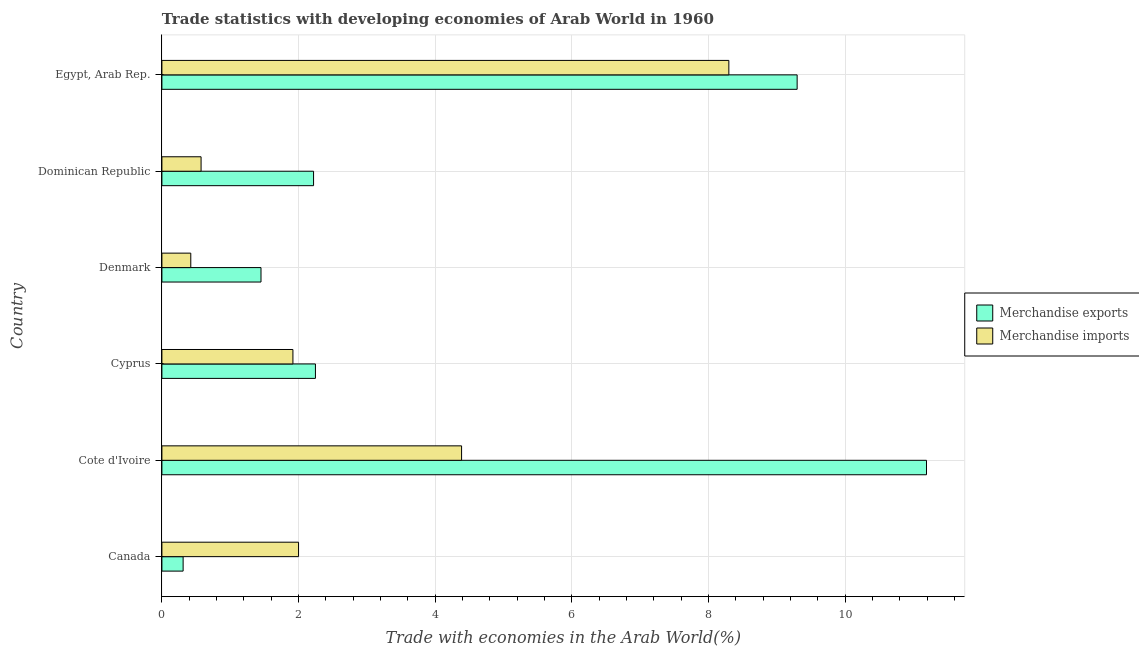How many different coloured bars are there?
Your response must be concise. 2. Are the number of bars per tick equal to the number of legend labels?
Keep it short and to the point. Yes. Are the number of bars on each tick of the Y-axis equal?
Offer a terse response. Yes. How many bars are there on the 6th tick from the bottom?
Your response must be concise. 2. What is the label of the 2nd group of bars from the top?
Offer a very short reply. Dominican Republic. What is the merchandise imports in Egypt, Arab Rep.?
Your response must be concise. 8.3. Across all countries, what is the maximum merchandise exports?
Ensure brevity in your answer.  11.19. Across all countries, what is the minimum merchandise imports?
Ensure brevity in your answer.  0.42. In which country was the merchandise exports maximum?
Give a very brief answer. Cote d'Ivoire. What is the total merchandise imports in the graph?
Your answer should be very brief. 17.6. What is the difference between the merchandise imports in Cote d'Ivoire and that in Dominican Republic?
Your answer should be very brief. 3.81. What is the difference between the merchandise exports in Cote d'Ivoire and the merchandise imports in Egypt, Arab Rep.?
Give a very brief answer. 2.89. What is the average merchandise imports per country?
Make the answer very short. 2.93. What is the difference between the merchandise imports and merchandise exports in Cyprus?
Give a very brief answer. -0.33. In how many countries, is the merchandise exports greater than 4.8 %?
Your answer should be compact. 2. What is the ratio of the merchandise imports in Cote d'Ivoire to that in Cyprus?
Your response must be concise. 2.29. Is the merchandise imports in Cyprus less than that in Egypt, Arab Rep.?
Ensure brevity in your answer.  Yes. Is the difference between the merchandise exports in Canada and Dominican Republic greater than the difference between the merchandise imports in Canada and Dominican Republic?
Provide a short and direct response. No. What is the difference between the highest and the second highest merchandise exports?
Your answer should be very brief. 1.89. What is the difference between the highest and the lowest merchandise exports?
Give a very brief answer. 10.88. Is the sum of the merchandise exports in Cyprus and Dominican Republic greater than the maximum merchandise imports across all countries?
Your response must be concise. No. How many countries are there in the graph?
Provide a short and direct response. 6. Are the values on the major ticks of X-axis written in scientific E-notation?
Ensure brevity in your answer.  No. Does the graph contain any zero values?
Your answer should be very brief. No. What is the title of the graph?
Your answer should be very brief. Trade statistics with developing economies of Arab World in 1960. Does "All education staff compensation" appear as one of the legend labels in the graph?
Your answer should be compact. No. What is the label or title of the X-axis?
Your response must be concise. Trade with economies in the Arab World(%). What is the Trade with economies in the Arab World(%) of Merchandise exports in Canada?
Provide a short and direct response. 0.31. What is the Trade with economies in the Arab World(%) in Merchandise exports in Cote d'Ivoire?
Your answer should be very brief. 11.19. What is the Trade with economies in the Arab World(%) in Merchandise imports in Cote d'Ivoire?
Your answer should be very brief. 4.39. What is the Trade with economies in the Arab World(%) in Merchandise exports in Cyprus?
Keep it short and to the point. 2.25. What is the Trade with economies in the Arab World(%) in Merchandise imports in Cyprus?
Your response must be concise. 1.92. What is the Trade with economies in the Arab World(%) of Merchandise exports in Denmark?
Make the answer very short. 1.45. What is the Trade with economies in the Arab World(%) in Merchandise imports in Denmark?
Offer a terse response. 0.42. What is the Trade with economies in the Arab World(%) in Merchandise exports in Dominican Republic?
Your answer should be compact. 2.22. What is the Trade with economies in the Arab World(%) in Merchandise imports in Dominican Republic?
Offer a very short reply. 0.57. What is the Trade with economies in the Arab World(%) in Merchandise exports in Egypt, Arab Rep.?
Ensure brevity in your answer.  9.3. What is the Trade with economies in the Arab World(%) of Merchandise imports in Egypt, Arab Rep.?
Offer a very short reply. 8.3. Across all countries, what is the maximum Trade with economies in the Arab World(%) of Merchandise exports?
Ensure brevity in your answer.  11.19. Across all countries, what is the maximum Trade with economies in the Arab World(%) of Merchandise imports?
Offer a very short reply. 8.3. Across all countries, what is the minimum Trade with economies in the Arab World(%) of Merchandise exports?
Offer a terse response. 0.31. Across all countries, what is the minimum Trade with economies in the Arab World(%) in Merchandise imports?
Provide a short and direct response. 0.42. What is the total Trade with economies in the Arab World(%) of Merchandise exports in the graph?
Keep it short and to the point. 26.72. What is the total Trade with economies in the Arab World(%) of Merchandise imports in the graph?
Keep it short and to the point. 17.6. What is the difference between the Trade with economies in the Arab World(%) in Merchandise exports in Canada and that in Cote d'Ivoire?
Offer a very short reply. -10.88. What is the difference between the Trade with economies in the Arab World(%) in Merchandise imports in Canada and that in Cote d'Ivoire?
Your answer should be compact. -2.39. What is the difference between the Trade with economies in the Arab World(%) of Merchandise exports in Canada and that in Cyprus?
Your answer should be very brief. -1.94. What is the difference between the Trade with economies in the Arab World(%) in Merchandise imports in Canada and that in Cyprus?
Provide a succinct answer. 0.08. What is the difference between the Trade with economies in the Arab World(%) of Merchandise exports in Canada and that in Denmark?
Make the answer very short. -1.14. What is the difference between the Trade with economies in the Arab World(%) of Merchandise imports in Canada and that in Denmark?
Your response must be concise. 1.58. What is the difference between the Trade with economies in the Arab World(%) in Merchandise exports in Canada and that in Dominican Republic?
Your answer should be compact. -1.91. What is the difference between the Trade with economies in the Arab World(%) of Merchandise imports in Canada and that in Dominican Republic?
Provide a succinct answer. 1.43. What is the difference between the Trade with economies in the Arab World(%) in Merchandise exports in Canada and that in Egypt, Arab Rep.?
Provide a short and direct response. -8.99. What is the difference between the Trade with economies in the Arab World(%) in Merchandise imports in Canada and that in Egypt, Arab Rep.?
Give a very brief answer. -6.3. What is the difference between the Trade with economies in the Arab World(%) in Merchandise exports in Cote d'Ivoire and that in Cyprus?
Provide a succinct answer. 8.94. What is the difference between the Trade with economies in the Arab World(%) in Merchandise imports in Cote d'Ivoire and that in Cyprus?
Provide a short and direct response. 2.47. What is the difference between the Trade with economies in the Arab World(%) of Merchandise exports in Cote d'Ivoire and that in Denmark?
Provide a short and direct response. 9.74. What is the difference between the Trade with economies in the Arab World(%) of Merchandise imports in Cote d'Ivoire and that in Denmark?
Provide a short and direct response. 3.96. What is the difference between the Trade with economies in the Arab World(%) in Merchandise exports in Cote d'Ivoire and that in Dominican Republic?
Offer a very short reply. 8.97. What is the difference between the Trade with economies in the Arab World(%) in Merchandise imports in Cote d'Ivoire and that in Dominican Republic?
Ensure brevity in your answer.  3.81. What is the difference between the Trade with economies in the Arab World(%) of Merchandise exports in Cote d'Ivoire and that in Egypt, Arab Rep.?
Give a very brief answer. 1.89. What is the difference between the Trade with economies in the Arab World(%) of Merchandise imports in Cote d'Ivoire and that in Egypt, Arab Rep.?
Offer a terse response. -3.91. What is the difference between the Trade with economies in the Arab World(%) of Merchandise exports in Cyprus and that in Denmark?
Ensure brevity in your answer.  0.8. What is the difference between the Trade with economies in the Arab World(%) in Merchandise imports in Cyprus and that in Denmark?
Keep it short and to the point. 1.5. What is the difference between the Trade with economies in the Arab World(%) of Merchandise exports in Cyprus and that in Dominican Republic?
Provide a short and direct response. 0.03. What is the difference between the Trade with economies in the Arab World(%) in Merchandise imports in Cyprus and that in Dominican Republic?
Your answer should be very brief. 1.34. What is the difference between the Trade with economies in the Arab World(%) in Merchandise exports in Cyprus and that in Egypt, Arab Rep.?
Keep it short and to the point. -7.05. What is the difference between the Trade with economies in the Arab World(%) of Merchandise imports in Cyprus and that in Egypt, Arab Rep.?
Offer a very short reply. -6.38. What is the difference between the Trade with economies in the Arab World(%) in Merchandise exports in Denmark and that in Dominican Republic?
Ensure brevity in your answer.  -0.77. What is the difference between the Trade with economies in the Arab World(%) of Merchandise imports in Denmark and that in Dominican Republic?
Offer a very short reply. -0.15. What is the difference between the Trade with economies in the Arab World(%) of Merchandise exports in Denmark and that in Egypt, Arab Rep.?
Make the answer very short. -7.85. What is the difference between the Trade with economies in the Arab World(%) of Merchandise imports in Denmark and that in Egypt, Arab Rep.?
Your answer should be compact. -7.88. What is the difference between the Trade with economies in the Arab World(%) of Merchandise exports in Dominican Republic and that in Egypt, Arab Rep.?
Your response must be concise. -7.08. What is the difference between the Trade with economies in the Arab World(%) of Merchandise imports in Dominican Republic and that in Egypt, Arab Rep.?
Provide a succinct answer. -7.72. What is the difference between the Trade with economies in the Arab World(%) in Merchandise exports in Canada and the Trade with economies in the Arab World(%) in Merchandise imports in Cote d'Ivoire?
Your response must be concise. -4.08. What is the difference between the Trade with economies in the Arab World(%) of Merchandise exports in Canada and the Trade with economies in the Arab World(%) of Merchandise imports in Cyprus?
Make the answer very short. -1.61. What is the difference between the Trade with economies in the Arab World(%) in Merchandise exports in Canada and the Trade with economies in the Arab World(%) in Merchandise imports in Denmark?
Your response must be concise. -0.11. What is the difference between the Trade with economies in the Arab World(%) in Merchandise exports in Canada and the Trade with economies in the Arab World(%) in Merchandise imports in Dominican Republic?
Make the answer very short. -0.26. What is the difference between the Trade with economies in the Arab World(%) of Merchandise exports in Canada and the Trade with economies in the Arab World(%) of Merchandise imports in Egypt, Arab Rep.?
Your answer should be compact. -7.99. What is the difference between the Trade with economies in the Arab World(%) of Merchandise exports in Cote d'Ivoire and the Trade with economies in the Arab World(%) of Merchandise imports in Cyprus?
Provide a short and direct response. 9.27. What is the difference between the Trade with economies in the Arab World(%) of Merchandise exports in Cote d'Ivoire and the Trade with economies in the Arab World(%) of Merchandise imports in Denmark?
Offer a very short reply. 10.77. What is the difference between the Trade with economies in the Arab World(%) in Merchandise exports in Cote d'Ivoire and the Trade with economies in the Arab World(%) in Merchandise imports in Dominican Republic?
Provide a succinct answer. 10.62. What is the difference between the Trade with economies in the Arab World(%) of Merchandise exports in Cote d'Ivoire and the Trade with economies in the Arab World(%) of Merchandise imports in Egypt, Arab Rep.?
Offer a terse response. 2.89. What is the difference between the Trade with economies in the Arab World(%) of Merchandise exports in Cyprus and the Trade with economies in the Arab World(%) of Merchandise imports in Denmark?
Offer a terse response. 1.82. What is the difference between the Trade with economies in the Arab World(%) in Merchandise exports in Cyprus and the Trade with economies in the Arab World(%) in Merchandise imports in Dominican Republic?
Offer a terse response. 1.67. What is the difference between the Trade with economies in the Arab World(%) of Merchandise exports in Cyprus and the Trade with economies in the Arab World(%) of Merchandise imports in Egypt, Arab Rep.?
Keep it short and to the point. -6.05. What is the difference between the Trade with economies in the Arab World(%) of Merchandise exports in Denmark and the Trade with economies in the Arab World(%) of Merchandise imports in Dominican Republic?
Your answer should be very brief. 0.88. What is the difference between the Trade with economies in the Arab World(%) in Merchandise exports in Denmark and the Trade with economies in the Arab World(%) in Merchandise imports in Egypt, Arab Rep.?
Ensure brevity in your answer.  -6.85. What is the difference between the Trade with economies in the Arab World(%) in Merchandise exports in Dominican Republic and the Trade with economies in the Arab World(%) in Merchandise imports in Egypt, Arab Rep.?
Provide a short and direct response. -6.08. What is the average Trade with economies in the Arab World(%) of Merchandise exports per country?
Keep it short and to the point. 4.45. What is the average Trade with economies in the Arab World(%) of Merchandise imports per country?
Your answer should be compact. 2.93. What is the difference between the Trade with economies in the Arab World(%) of Merchandise exports and Trade with economies in the Arab World(%) of Merchandise imports in Canada?
Provide a short and direct response. -1.69. What is the difference between the Trade with economies in the Arab World(%) in Merchandise exports and Trade with economies in the Arab World(%) in Merchandise imports in Cote d'Ivoire?
Your answer should be compact. 6.8. What is the difference between the Trade with economies in the Arab World(%) in Merchandise exports and Trade with economies in the Arab World(%) in Merchandise imports in Cyprus?
Your response must be concise. 0.33. What is the difference between the Trade with economies in the Arab World(%) in Merchandise exports and Trade with economies in the Arab World(%) in Merchandise imports in Denmark?
Your answer should be very brief. 1.03. What is the difference between the Trade with economies in the Arab World(%) of Merchandise exports and Trade with economies in the Arab World(%) of Merchandise imports in Dominican Republic?
Ensure brevity in your answer.  1.65. What is the ratio of the Trade with economies in the Arab World(%) of Merchandise exports in Canada to that in Cote d'Ivoire?
Provide a succinct answer. 0.03. What is the ratio of the Trade with economies in the Arab World(%) in Merchandise imports in Canada to that in Cote d'Ivoire?
Your response must be concise. 0.46. What is the ratio of the Trade with economies in the Arab World(%) in Merchandise exports in Canada to that in Cyprus?
Offer a terse response. 0.14. What is the ratio of the Trade with economies in the Arab World(%) in Merchandise imports in Canada to that in Cyprus?
Give a very brief answer. 1.04. What is the ratio of the Trade with economies in the Arab World(%) of Merchandise exports in Canada to that in Denmark?
Make the answer very short. 0.21. What is the ratio of the Trade with economies in the Arab World(%) in Merchandise imports in Canada to that in Denmark?
Make the answer very short. 4.73. What is the ratio of the Trade with economies in the Arab World(%) of Merchandise exports in Canada to that in Dominican Republic?
Offer a very short reply. 0.14. What is the ratio of the Trade with economies in the Arab World(%) of Merchandise imports in Canada to that in Dominican Republic?
Offer a terse response. 3.49. What is the ratio of the Trade with economies in the Arab World(%) of Merchandise exports in Canada to that in Egypt, Arab Rep.?
Offer a very short reply. 0.03. What is the ratio of the Trade with economies in the Arab World(%) of Merchandise imports in Canada to that in Egypt, Arab Rep.?
Keep it short and to the point. 0.24. What is the ratio of the Trade with economies in the Arab World(%) in Merchandise exports in Cote d'Ivoire to that in Cyprus?
Offer a very short reply. 4.98. What is the ratio of the Trade with economies in the Arab World(%) in Merchandise imports in Cote d'Ivoire to that in Cyprus?
Ensure brevity in your answer.  2.29. What is the ratio of the Trade with economies in the Arab World(%) of Merchandise exports in Cote d'Ivoire to that in Denmark?
Give a very brief answer. 7.72. What is the ratio of the Trade with economies in the Arab World(%) of Merchandise imports in Cote d'Ivoire to that in Denmark?
Keep it short and to the point. 10.37. What is the ratio of the Trade with economies in the Arab World(%) of Merchandise exports in Cote d'Ivoire to that in Dominican Republic?
Your response must be concise. 5.04. What is the ratio of the Trade with economies in the Arab World(%) of Merchandise imports in Cote d'Ivoire to that in Dominican Republic?
Your answer should be very brief. 7.65. What is the ratio of the Trade with economies in the Arab World(%) of Merchandise exports in Cote d'Ivoire to that in Egypt, Arab Rep.?
Your answer should be compact. 1.2. What is the ratio of the Trade with economies in the Arab World(%) in Merchandise imports in Cote d'Ivoire to that in Egypt, Arab Rep.?
Your response must be concise. 0.53. What is the ratio of the Trade with economies in the Arab World(%) of Merchandise exports in Cyprus to that in Denmark?
Ensure brevity in your answer.  1.55. What is the ratio of the Trade with economies in the Arab World(%) in Merchandise imports in Cyprus to that in Denmark?
Your answer should be compact. 4.54. What is the ratio of the Trade with economies in the Arab World(%) of Merchandise exports in Cyprus to that in Dominican Republic?
Ensure brevity in your answer.  1.01. What is the ratio of the Trade with economies in the Arab World(%) of Merchandise imports in Cyprus to that in Dominican Republic?
Ensure brevity in your answer.  3.34. What is the ratio of the Trade with economies in the Arab World(%) in Merchandise exports in Cyprus to that in Egypt, Arab Rep.?
Give a very brief answer. 0.24. What is the ratio of the Trade with economies in the Arab World(%) in Merchandise imports in Cyprus to that in Egypt, Arab Rep.?
Give a very brief answer. 0.23. What is the ratio of the Trade with economies in the Arab World(%) in Merchandise exports in Denmark to that in Dominican Republic?
Offer a very short reply. 0.65. What is the ratio of the Trade with economies in the Arab World(%) of Merchandise imports in Denmark to that in Dominican Republic?
Make the answer very short. 0.74. What is the ratio of the Trade with economies in the Arab World(%) of Merchandise exports in Denmark to that in Egypt, Arab Rep.?
Provide a succinct answer. 0.16. What is the ratio of the Trade with economies in the Arab World(%) in Merchandise imports in Denmark to that in Egypt, Arab Rep.?
Give a very brief answer. 0.05. What is the ratio of the Trade with economies in the Arab World(%) of Merchandise exports in Dominican Republic to that in Egypt, Arab Rep.?
Provide a succinct answer. 0.24. What is the ratio of the Trade with economies in the Arab World(%) of Merchandise imports in Dominican Republic to that in Egypt, Arab Rep.?
Your answer should be compact. 0.07. What is the difference between the highest and the second highest Trade with economies in the Arab World(%) of Merchandise exports?
Provide a succinct answer. 1.89. What is the difference between the highest and the second highest Trade with economies in the Arab World(%) of Merchandise imports?
Ensure brevity in your answer.  3.91. What is the difference between the highest and the lowest Trade with economies in the Arab World(%) in Merchandise exports?
Your response must be concise. 10.88. What is the difference between the highest and the lowest Trade with economies in the Arab World(%) in Merchandise imports?
Your answer should be very brief. 7.88. 